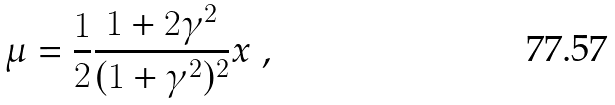<formula> <loc_0><loc_0><loc_500><loc_500>\mu = \frac { 1 } { 2 } \frac { 1 + 2 \gamma ^ { 2 } } { ( 1 + \gamma ^ { 2 } ) ^ { 2 } } x \ ,</formula> 